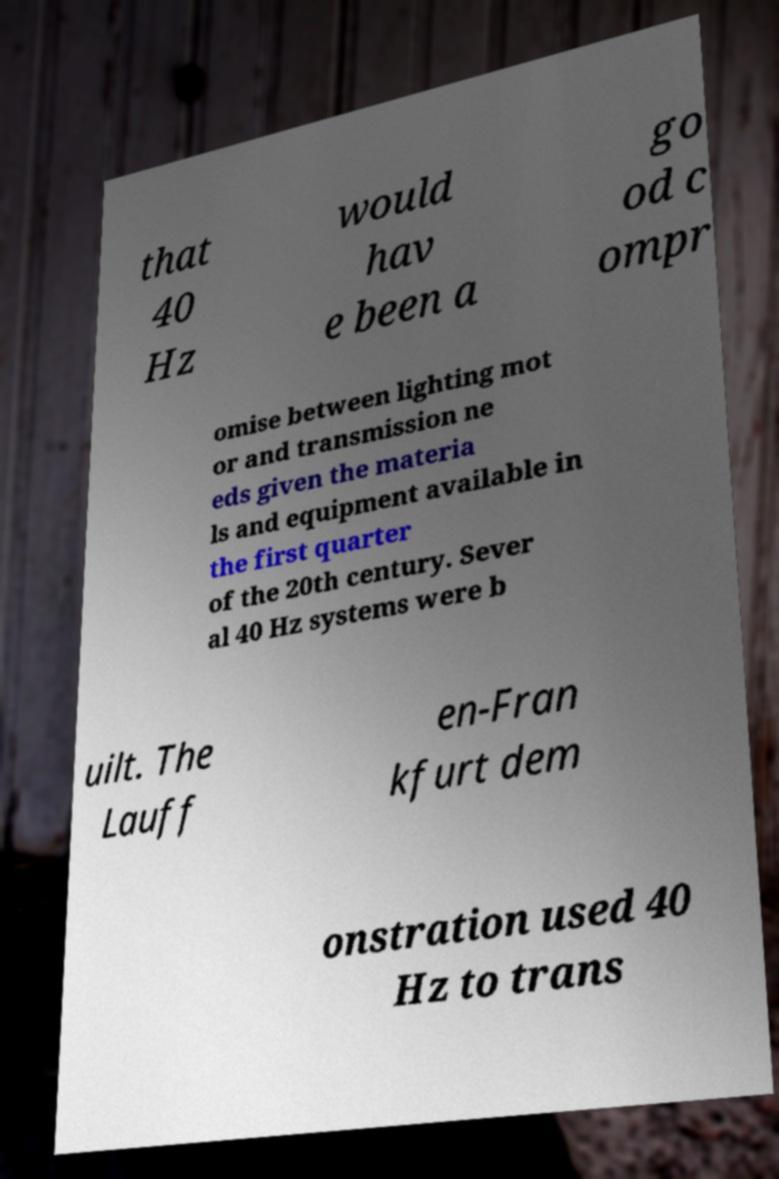Could you assist in decoding the text presented in this image and type it out clearly? that 40 Hz would hav e been a go od c ompr omise between lighting mot or and transmission ne eds given the materia ls and equipment available in the first quarter of the 20th century. Sever al 40 Hz systems were b uilt. The Lauff en-Fran kfurt dem onstration used 40 Hz to trans 